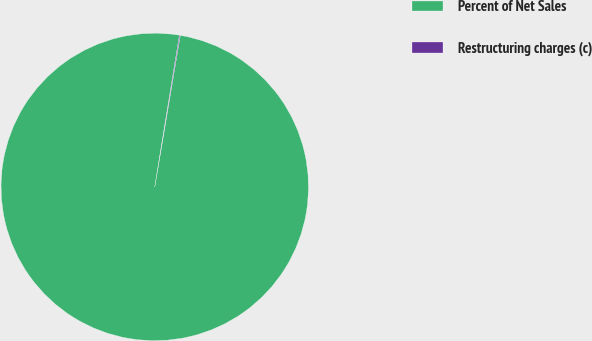Convert chart to OTSL. <chart><loc_0><loc_0><loc_500><loc_500><pie_chart><fcel>Percent of Net Sales<fcel>Restructuring charges (c)<nl><fcel>99.92%<fcel>0.08%<nl></chart> 